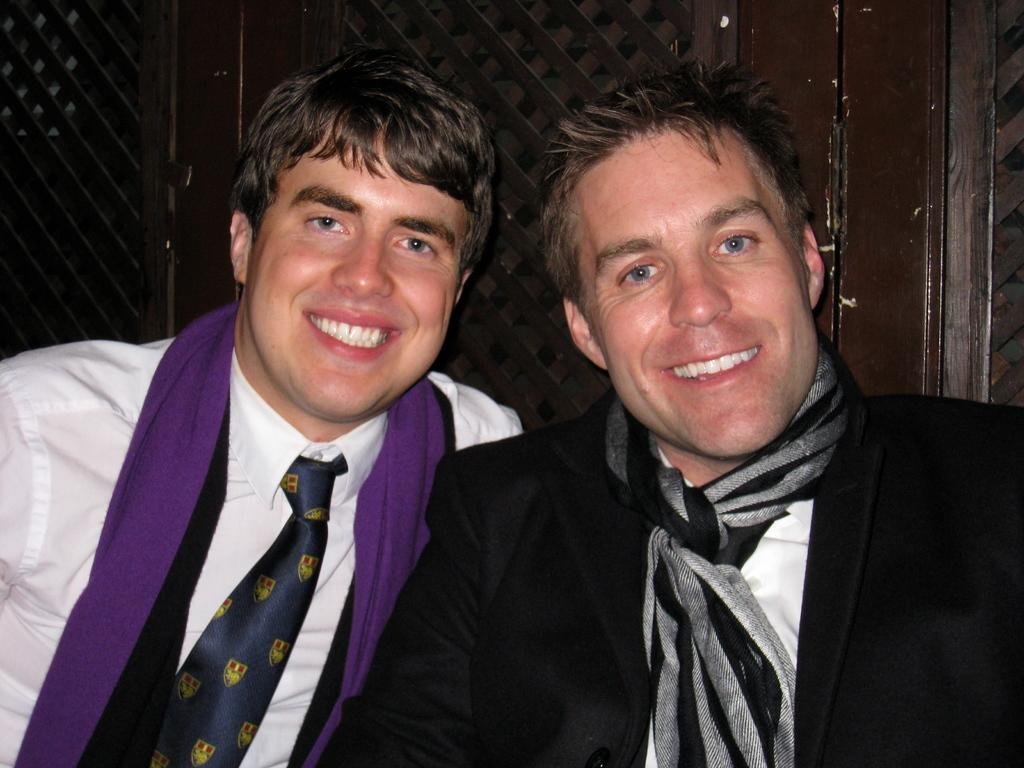How many people are in the image? There are two people in the image. What is the facial expression of the people in the image? The people are smiling. What can be seen in the background of the image? There is a wooden wall in the background of the image. How many girls are in the image? The provided facts do not specify the gender of the people in the image, so we cannot determine the number of girls. 